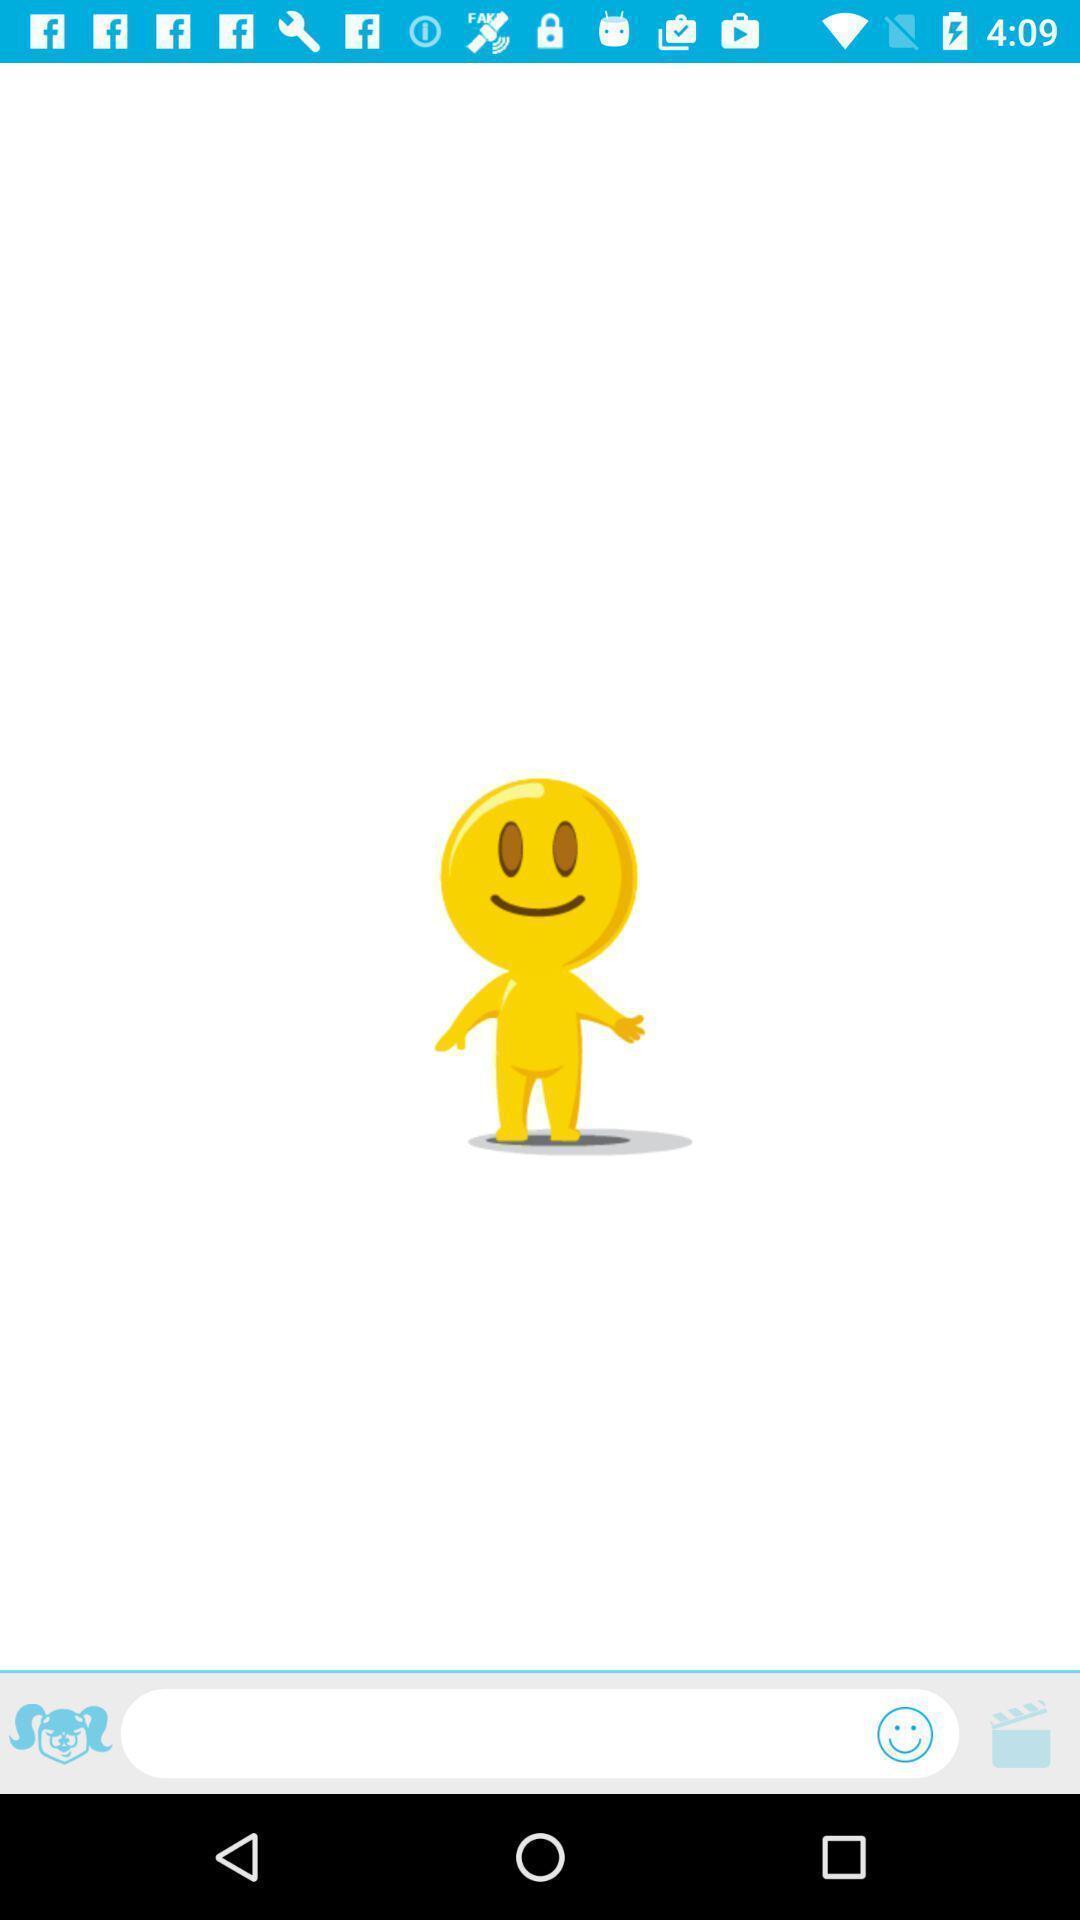Tell me about the visual elements in this screen capture. Page displaying with a cartoon emoji. 